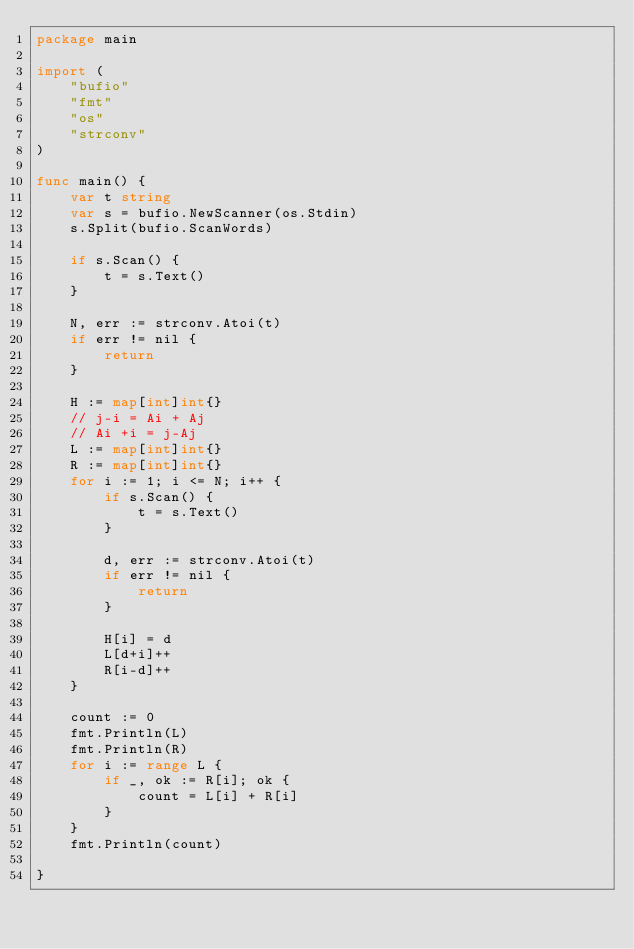<code> <loc_0><loc_0><loc_500><loc_500><_Go_>package main

import (
	"bufio"
	"fmt"
	"os"
	"strconv"
)

func main() {
	var t string
	var s = bufio.NewScanner(os.Stdin)
	s.Split(bufio.ScanWords)

	if s.Scan() {
		t = s.Text()
	}

	N, err := strconv.Atoi(t)
	if err != nil {
		return
	}

	H := map[int]int{}
	// j-i = Ai + Aj
	// Ai +i = j-Aj
	L := map[int]int{}
	R := map[int]int{}
	for i := 1; i <= N; i++ {
		if s.Scan() {
			t = s.Text()
		}

		d, err := strconv.Atoi(t)
		if err != nil {
			return
		}

		H[i] = d
		L[d+i]++
		R[i-d]++
	}

	count := 0
	fmt.Println(L)
	fmt.Println(R)
	for i := range L {
		if _, ok := R[i]; ok {
			count = L[i] + R[i]
		}
	}
	fmt.Println(count)

}
</code> 